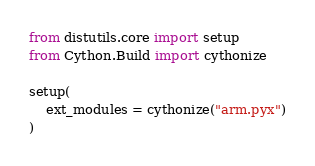Convert code to text. <code><loc_0><loc_0><loc_500><loc_500><_Python_>from distutils.core import setup
from Cython.Build import cythonize

setup(
    ext_modules = cythonize("arm.pyx")
)</code> 